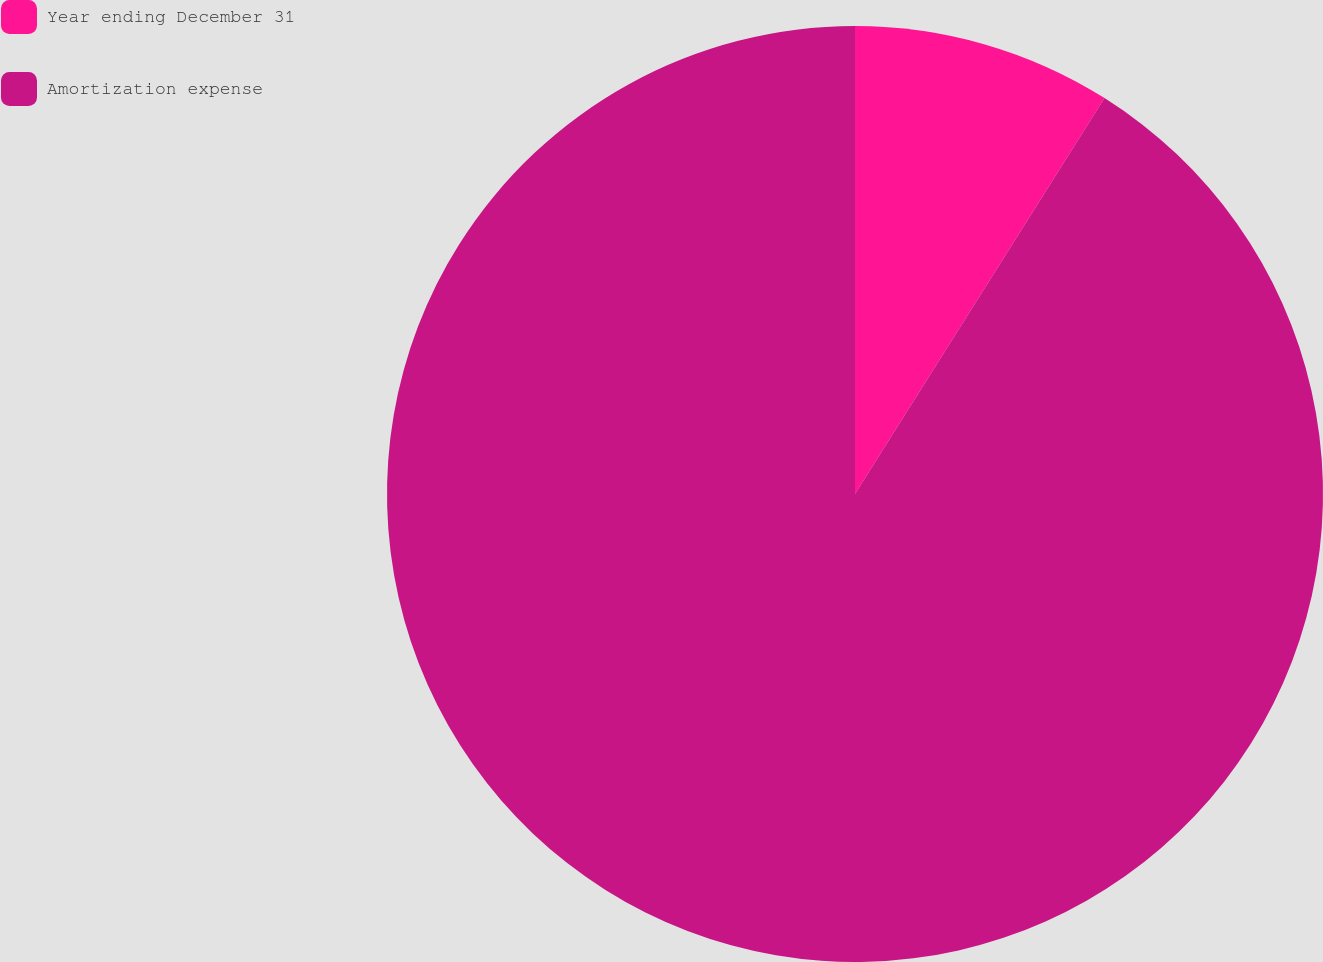<chart> <loc_0><loc_0><loc_500><loc_500><pie_chart><fcel>Year ending December 31<fcel>Amortization expense<nl><fcel>8.95%<fcel>91.05%<nl></chart> 